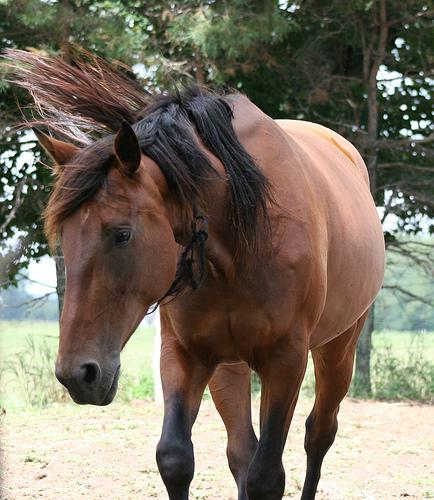Question: what color are the tree leaves?
Choices:
A. Red.
B. Orange.
C. Green.
D. Brown.
Answer with the letter. Answer: C Question: what is the animal doing?
Choices:
A. It is running.
B. It is sleeping.
C. It is walking.
D. It is eating.
Answer with the letter. Answer: C Question: where was the photo taken?
Choices:
A. A field.
B. The boys house.
C. Next door.
D. At the lake.
Answer with the letter. Answer: A Question: what animal is this?
Choices:
A. A dog.
B. A tiger.
C. A horse.
D. A moose.
Answer with the letter. Answer: C Question: how many animals are pictured?
Choices:
A. Two.
B. One.
C. Three.
D. Four.
Answer with the letter. Answer: B Question: why was the photo taken?
Choices:
A. To show a birthday.
B. To show the animal.
C. To show a house.
D. To show people posing.
Answer with the letter. Answer: B 